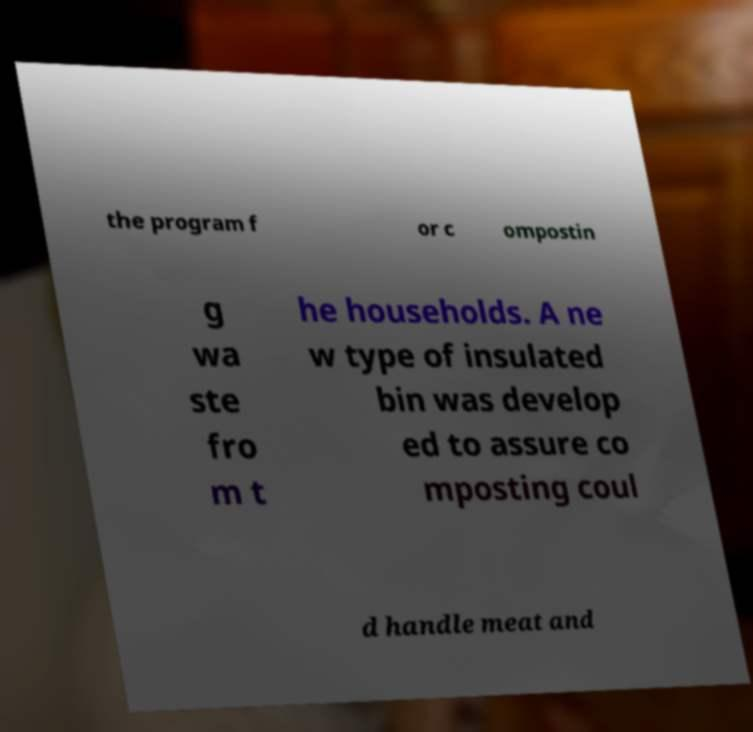I need the written content from this picture converted into text. Can you do that? the program f or c ompostin g wa ste fro m t he households. A ne w type of insulated bin was develop ed to assure co mposting coul d handle meat and 